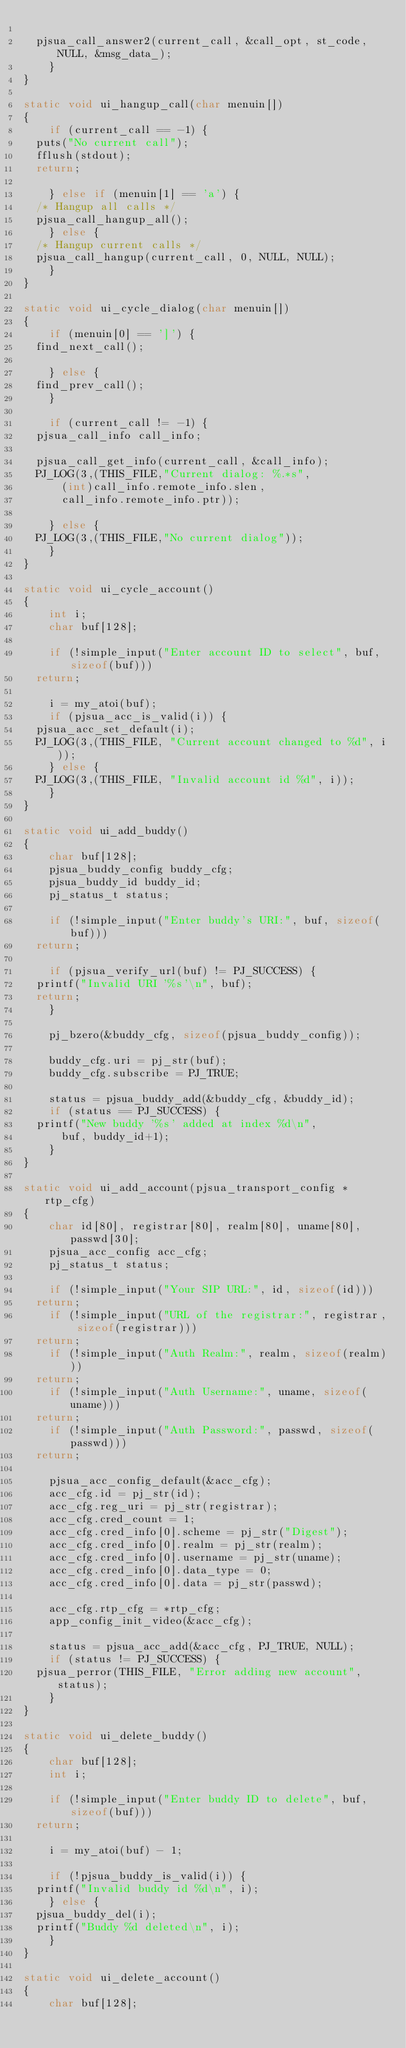<code> <loc_0><loc_0><loc_500><loc_500><_C_>
	pjsua_call_answer2(current_call, &call_opt, st_code, NULL, &msg_data_);
    }
}

static void ui_hangup_call(char menuin[])
{
    if (current_call == -1) {
	puts("No current call");
	fflush(stdout);
	return;

    } else if (menuin[1] == 'a') {
	/* Hangup all calls */
	pjsua_call_hangup_all();
    } else {
	/* Hangup current calls */
	pjsua_call_hangup(current_call, 0, NULL, NULL);
    }
}

static void ui_cycle_dialog(char menuin[])
{
    if (menuin[0] == ']') {
	find_next_call();

    } else {
	find_prev_call();
    }

    if (current_call != -1) {
	pjsua_call_info call_info;

	pjsua_call_get_info(current_call, &call_info);
	PJ_LOG(3,(THIS_FILE,"Current dialog: %.*s",
	    (int)call_info.remote_info.slen,
	    call_info.remote_info.ptr));

    } else {
	PJ_LOG(3,(THIS_FILE,"No current dialog"));
    }
}

static void ui_cycle_account()
{
    int i;
    char buf[128];

    if (!simple_input("Enter account ID to select", buf, sizeof(buf)))
	return;

    i = my_atoi(buf);
    if (pjsua_acc_is_valid(i)) {
	pjsua_acc_set_default(i);
	PJ_LOG(3,(THIS_FILE, "Current account changed to %d", i));
    } else {
	PJ_LOG(3,(THIS_FILE, "Invalid account id %d", i));
    }
}

static void ui_add_buddy()
{
    char buf[128];
    pjsua_buddy_config buddy_cfg;
    pjsua_buddy_id buddy_id;
    pj_status_t status;

    if (!simple_input("Enter buddy's URI:", buf, sizeof(buf)))
	return;

    if (pjsua_verify_url(buf) != PJ_SUCCESS) {
	printf("Invalid URI '%s'\n", buf);
	return;
    }

    pj_bzero(&buddy_cfg, sizeof(pjsua_buddy_config));

    buddy_cfg.uri = pj_str(buf);
    buddy_cfg.subscribe = PJ_TRUE;

    status = pjsua_buddy_add(&buddy_cfg, &buddy_id);
    if (status == PJ_SUCCESS) {
	printf("New buddy '%s' added at index %d\n",
	    buf, buddy_id+1);
    }
}

static void ui_add_account(pjsua_transport_config *rtp_cfg)
{
    char id[80], registrar[80], realm[80], uname[80], passwd[30];
    pjsua_acc_config acc_cfg;
    pj_status_t status;

    if (!simple_input("Your SIP URL:", id, sizeof(id)))
	return;
    if (!simple_input("URL of the registrar:", registrar, sizeof(registrar)))
	return;
    if (!simple_input("Auth Realm:", realm, sizeof(realm)))
	return;
    if (!simple_input("Auth Username:", uname, sizeof(uname)))
	return;
    if (!simple_input("Auth Password:", passwd, sizeof(passwd)))
	return;

    pjsua_acc_config_default(&acc_cfg);
    acc_cfg.id = pj_str(id);
    acc_cfg.reg_uri = pj_str(registrar);
    acc_cfg.cred_count = 1;
    acc_cfg.cred_info[0].scheme = pj_str("Digest");
    acc_cfg.cred_info[0].realm = pj_str(realm);
    acc_cfg.cred_info[0].username = pj_str(uname);
    acc_cfg.cred_info[0].data_type = 0;
    acc_cfg.cred_info[0].data = pj_str(passwd);

    acc_cfg.rtp_cfg = *rtp_cfg;
    app_config_init_video(&acc_cfg);

    status = pjsua_acc_add(&acc_cfg, PJ_TRUE, NULL);
    if (status != PJ_SUCCESS) {
	pjsua_perror(THIS_FILE, "Error adding new account", status);
    }
}

static void ui_delete_buddy()
{
    char buf[128];
    int i;

    if (!simple_input("Enter buddy ID to delete", buf, sizeof(buf)))
	return;

    i = my_atoi(buf) - 1;

    if (!pjsua_buddy_is_valid(i)) {
	printf("Invalid buddy id %d\n", i);
    } else {
	pjsua_buddy_del(i);
	printf("Buddy %d deleted\n", i);
    }
}

static void ui_delete_account()
{
    char buf[128];</code> 